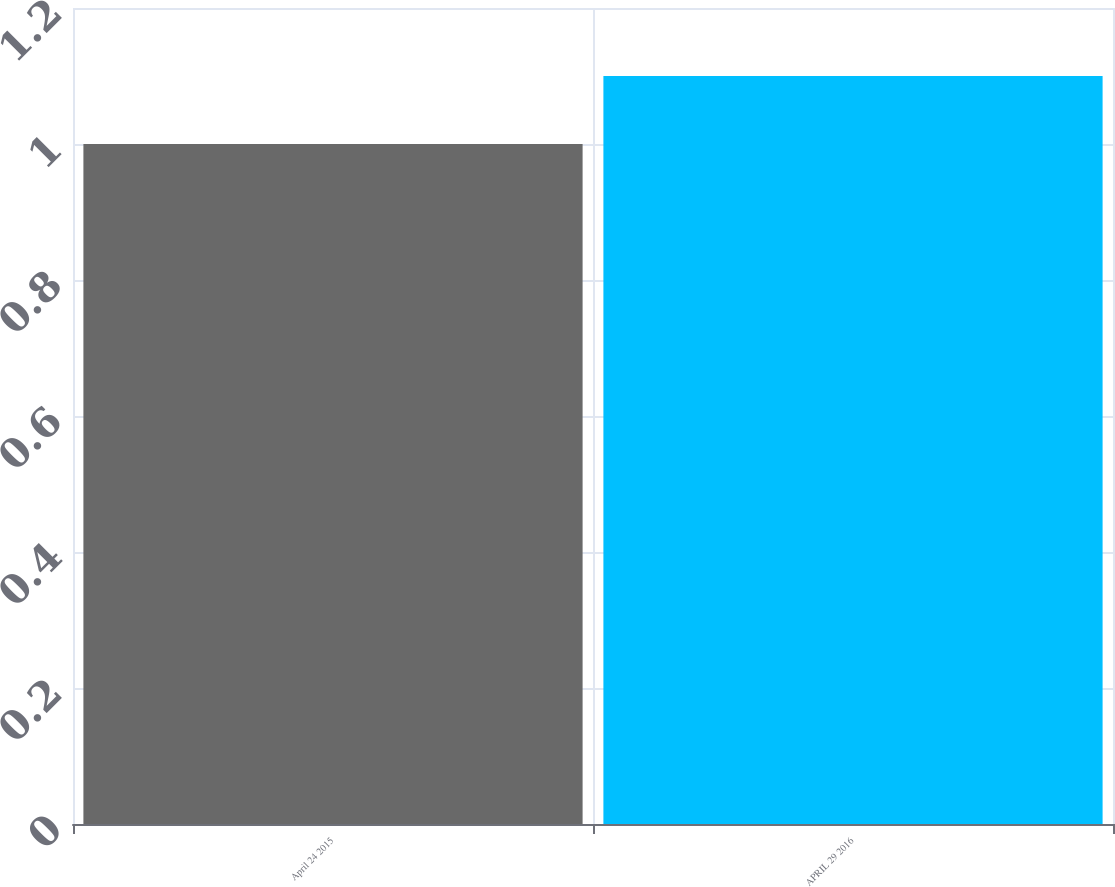Convert chart. <chart><loc_0><loc_0><loc_500><loc_500><bar_chart><fcel>April 24 2015<fcel>APRIL 29 2016<nl><fcel>1<fcel>1.1<nl></chart> 